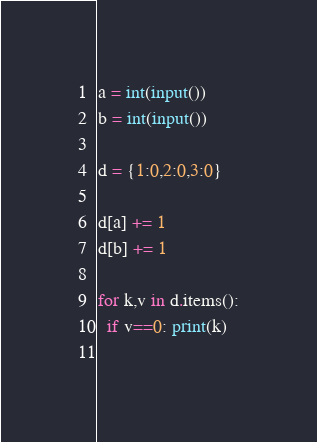Convert code to text. <code><loc_0><loc_0><loc_500><loc_500><_Python_>a = int(input())
b = int(input())

d = {1:0,2:0,3:0}

d[a] += 1
d[b] += 1

for k,v in d.items():
  if v==0: print(k)
  </code> 